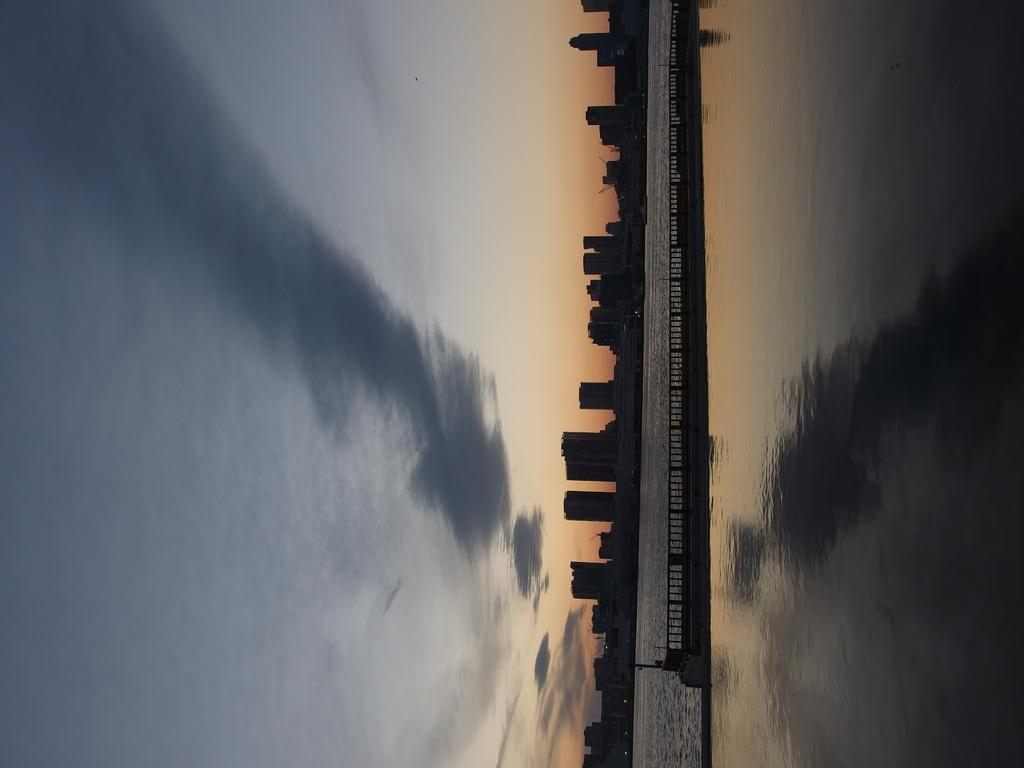What is located on the right side of the image? There is water on the right side of the image. What separates the water from the rest of the image? There is a wall with railings between the water. What can be seen in the background of the image? There are buildings visible in the background of the image, and the sky is also visible. What is the condition of the sky in the image? Clouds are present in the sky. What type of flower is growing on the wall in the image? There are no flowers present in the image; the wall has railings between the water and the rest of the scene. How does the digestion process appear in the image? There is no reference to digestion in the image; it features water, a wall with railings, buildings, and clouds in the sky. 